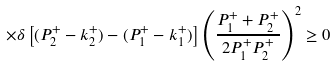<formula> <loc_0><loc_0><loc_500><loc_500>\times \delta \left [ ( P _ { 2 } ^ { + } - k ^ { + } _ { 2 } ) - ( P _ { 1 } ^ { + } - k ^ { + } _ { 1 } ) \right ] \left ( \frac { P _ { 1 } ^ { + } + P _ { 2 } ^ { + } } { 2 P _ { 1 } ^ { + } P _ { 2 } ^ { + } } \right ) ^ { 2 } \geq 0</formula> 